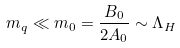<formula> <loc_0><loc_0><loc_500><loc_500>m _ { q } \ll m _ { 0 } = \frac { B _ { 0 } } { 2 A _ { 0 } } \sim \Lambda _ { H }</formula> 